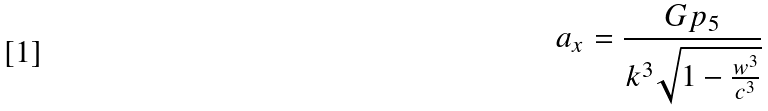<formula> <loc_0><loc_0><loc_500><loc_500>a _ { x } = \frac { G p _ { 5 } } { k ^ { 3 } \sqrt { 1 - \frac { w ^ { 3 } } { c ^ { 3 } } } }</formula> 